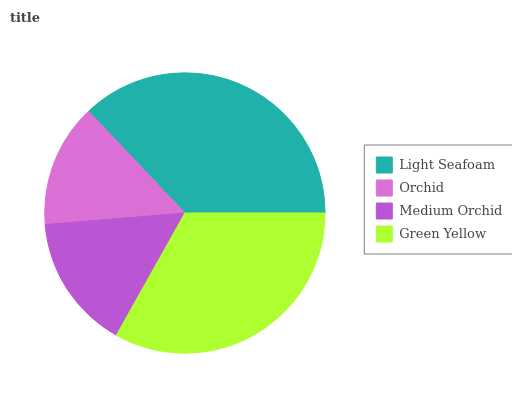Is Orchid the minimum?
Answer yes or no. Yes. Is Light Seafoam the maximum?
Answer yes or no. Yes. Is Medium Orchid the minimum?
Answer yes or no. No. Is Medium Orchid the maximum?
Answer yes or no. No. Is Medium Orchid greater than Orchid?
Answer yes or no. Yes. Is Orchid less than Medium Orchid?
Answer yes or no. Yes. Is Orchid greater than Medium Orchid?
Answer yes or no. No. Is Medium Orchid less than Orchid?
Answer yes or no. No. Is Green Yellow the high median?
Answer yes or no. Yes. Is Medium Orchid the low median?
Answer yes or no. Yes. Is Orchid the high median?
Answer yes or no. No. Is Light Seafoam the low median?
Answer yes or no. No. 